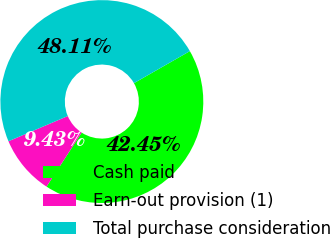<chart> <loc_0><loc_0><loc_500><loc_500><pie_chart><fcel>Cash paid<fcel>Earn-out provision (1)<fcel>Total purchase consideration<nl><fcel>42.45%<fcel>9.43%<fcel>48.11%<nl></chart> 